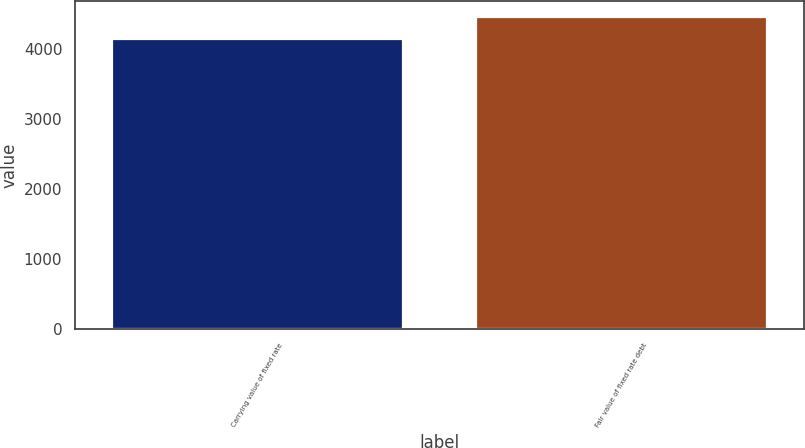Convert chart. <chart><loc_0><loc_0><loc_500><loc_500><bar_chart><fcel>Carrying value of fixed rate<fcel>Fair value of fixed rate debt<nl><fcel>4146<fcel>4470<nl></chart> 